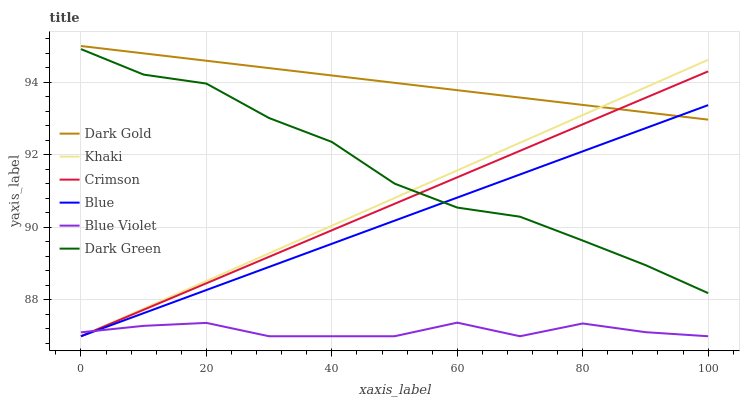Does Blue Violet have the minimum area under the curve?
Answer yes or no. Yes. Does Dark Gold have the maximum area under the curve?
Answer yes or no. Yes. Does Khaki have the minimum area under the curve?
Answer yes or no. No. Does Khaki have the maximum area under the curve?
Answer yes or no. No. Is Blue the smoothest?
Answer yes or no. Yes. Is Blue Violet the roughest?
Answer yes or no. Yes. Is Dark Gold the smoothest?
Answer yes or no. No. Is Dark Gold the roughest?
Answer yes or no. No. Does Blue have the lowest value?
Answer yes or no. Yes. Does Dark Gold have the lowest value?
Answer yes or no. No. Does Dark Gold have the highest value?
Answer yes or no. Yes. Does Khaki have the highest value?
Answer yes or no. No. Is Blue Violet less than Dark Green?
Answer yes or no. Yes. Is Dark Gold greater than Dark Green?
Answer yes or no. Yes. Does Khaki intersect Dark Green?
Answer yes or no. Yes. Is Khaki less than Dark Green?
Answer yes or no. No. Is Khaki greater than Dark Green?
Answer yes or no. No. Does Blue Violet intersect Dark Green?
Answer yes or no. No. 